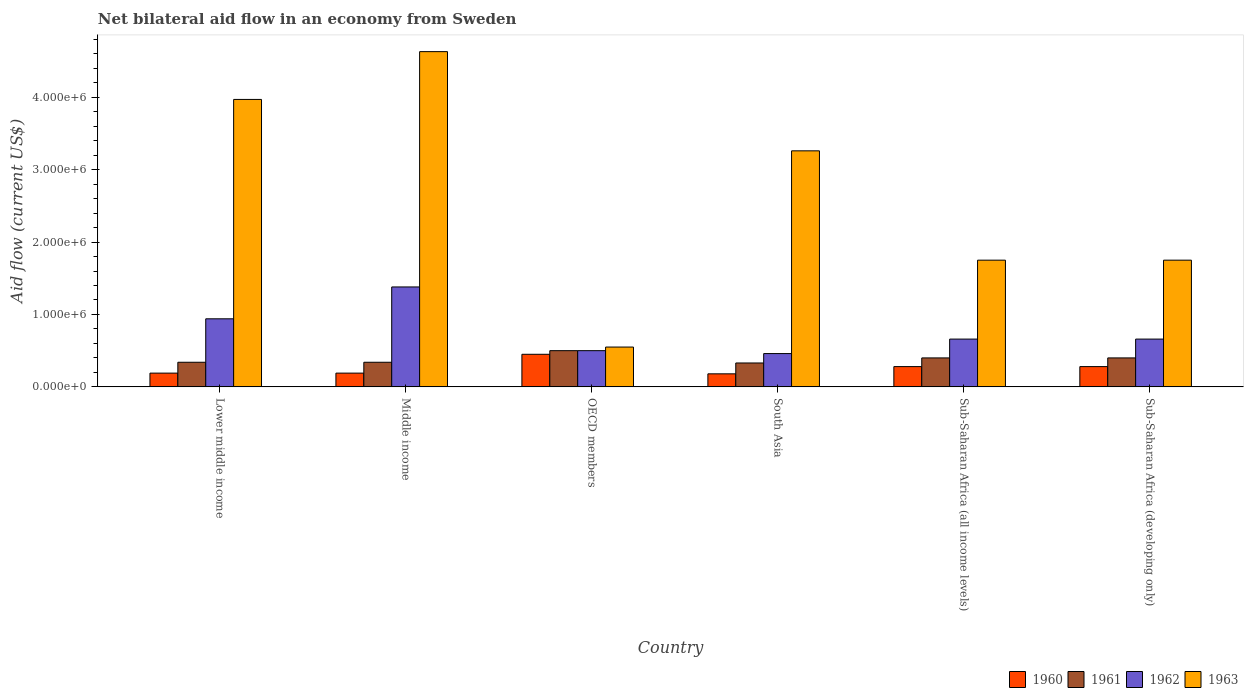How many different coloured bars are there?
Provide a short and direct response. 4. How many groups of bars are there?
Provide a succinct answer. 6. Are the number of bars on each tick of the X-axis equal?
Ensure brevity in your answer.  Yes. What is the label of the 5th group of bars from the left?
Your response must be concise. Sub-Saharan Africa (all income levels). What is the net bilateral aid flow in 1963 in Middle income?
Offer a very short reply. 4.63e+06. Across all countries, what is the maximum net bilateral aid flow in 1962?
Provide a succinct answer. 1.38e+06. Across all countries, what is the minimum net bilateral aid flow in 1960?
Your answer should be compact. 1.80e+05. In which country was the net bilateral aid flow in 1963 maximum?
Your response must be concise. Middle income. What is the total net bilateral aid flow in 1962 in the graph?
Provide a short and direct response. 4.60e+06. What is the difference between the net bilateral aid flow in 1961 in South Asia and that in Sub-Saharan Africa (all income levels)?
Make the answer very short. -7.00e+04. What is the difference between the net bilateral aid flow in 1962 in Sub-Saharan Africa (developing only) and the net bilateral aid flow in 1963 in Middle income?
Give a very brief answer. -3.97e+06. What is the average net bilateral aid flow in 1963 per country?
Your answer should be compact. 2.65e+06. What is the difference between the net bilateral aid flow of/in 1962 and net bilateral aid flow of/in 1961 in Middle income?
Keep it short and to the point. 1.04e+06. In how many countries, is the net bilateral aid flow in 1960 greater than 3200000 US$?
Offer a terse response. 0. What is the ratio of the net bilateral aid flow in 1961 in Sub-Saharan Africa (all income levels) to that in Sub-Saharan Africa (developing only)?
Offer a very short reply. 1. In how many countries, is the net bilateral aid flow in 1963 greater than the average net bilateral aid flow in 1963 taken over all countries?
Keep it short and to the point. 3. Is the sum of the net bilateral aid flow in 1960 in Middle income and OECD members greater than the maximum net bilateral aid flow in 1962 across all countries?
Your answer should be compact. No. What does the 4th bar from the left in Sub-Saharan Africa (developing only) represents?
Your response must be concise. 1963. What does the 2nd bar from the right in Sub-Saharan Africa (developing only) represents?
Make the answer very short. 1962. Is it the case that in every country, the sum of the net bilateral aid flow in 1960 and net bilateral aid flow in 1961 is greater than the net bilateral aid flow in 1962?
Offer a very short reply. No. How many bars are there?
Offer a very short reply. 24. Are all the bars in the graph horizontal?
Offer a very short reply. No. How many countries are there in the graph?
Offer a very short reply. 6. What is the difference between two consecutive major ticks on the Y-axis?
Your answer should be compact. 1.00e+06. Does the graph contain any zero values?
Offer a very short reply. No. How many legend labels are there?
Make the answer very short. 4. How are the legend labels stacked?
Your answer should be compact. Horizontal. What is the title of the graph?
Make the answer very short. Net bilateral aid flow in an economy from Sweden. Does "2004" appear as one of the legend labels in the graph?
Ensure brevity in your answer.  No. What is the label or title of the X-axis?
Your answer should be very brief. Country. What is the Aid flow (current US$) of 1961 in Lower middle income?
Your answer should be very brief. 3.40e+05. What is the Aid flow (current US$) of 1962 in Lower middle income?
Offer a very short reply. 9.40e+05. What is the Aid flow (current US$) in 1963 in Lower middle income?
Give a very brief answer. 3.97e+06. What is the Aid flow (current US$) of 1962 in Middle income?
Give a very brief answer. 1.38e+06. What is the Aid flow (current US$) of 1963 in Middle income?
Offer a very short reply. 4.63e+06. What is the Aid flow (current US$) in 1960 in OECD members?
Provide a succinct answer. 4.50e+05. What is the Aid flow (current US$) of 1962 in OECD members?
Your answer should be very brief. 5.00e+05. What is the Aid flow (current US$) in 1963 in OECD members?
Offer a very short reply. 5.50e+05. What is the Aid flow (current US$) in 1960 in South Asia?
Give a very brief answer. 1.80e+05. What is the Aid flow (current US$) in 1962 in South Asia?
Offer a terse response. 4.60e+05. What is the Aid flow (current US$) of 1963 in South Asia?
Give a very brief answer. 3.26e+06. What is the Aid flow (current US$) of 1963 in Sub-Saharan Africa (all income levels)?
Provide a short and direct response. 1.75e+06. What is the Aid flow (current US$) in 1962 in Sub-Saharan Africa (developing only)?
Ensure brevity in your answer.  6.60e+05. What is the Aid flow (current US$) of 1963 in Sub-Saharan Africa (developing only)?
Your response must be concise. 1.75e+06. Across all countries, what is the maximum Aid flow (current US$) in 1962?
Give a very brief answer. 1.38e+06. Across all countries, what is the maximum Aid flow (current US$) in 1963?
Your answer should be compact. 4.63e+06. Across all countries, what is the minimum Aid flow (current US$) of 1960?
Offer a very short reply. 1.80e+05. Across all countries, what is the minimum Aid flow (current US$) of 1961?
Ensure brevity in your answer.  3.30e+05. What is the total Aid flow (current US$) of 1960 in the graph?
Your response must be concise. 1.57e+06. What is the total Aid flow (current US$) in 1961 in the graph?
Ensure brevity in your answer.  2.31e+06. What is the total Aid flow (current US$) of 1962 in the graph?
Your answer should be compact. 4.60e+06. What is the total Aid flow (current US$) of 1963 in the graph?
Offer a terse response. 1.59e+07. What is the difference between the Aid flow (current US$) of 1960 in Lower middle income and that in Middle income?
Your response must be concise. 0. What is the difference between the Aid flow (current US$) of 1961 in Lower middle income and that in Middle income?
Ensure brevity in your answer.  0. What is the difference between the Aid flow (current US$) of 1962 in Lower middle income and that in Middle income?
Provide a short and direct response. -4.40e+05. What is the difference between the Aid flow (current US$) in 1963 in Lower middle income and that in Middle income?
Keep it short and to the point. -6.60e+05. What is the difference between the Aid flow (current US$) in 1960 in Lower middle income and that in OECD members?
Your response must be concise. -2.60e+05. What is the difference between the Aid flow (current US$) in 1962 in Lower middle income and that in OECD members?
Your answer should be very brief. 4.40e+05. What is the difference between the Aid flow (current US$) in 1963 in Lower middle income and that in OECD members?
Make the answer very short. 3.42e+06. What is the difference between the Aid flow (current US$) in 1961 in Lower middle income and that in South Asia?
Keep it short and to the point. 10000. What is the difference between the Aid flow (current US$) of 1962 in Lower middle income and that in South Asia?
Your answer should be very brief. 4.80e+05. What is the difference between the Aid flow (current US$) in 1963 in Lower middle income and that in South Asia?
Keep it short and to the point. 7.10e+05. What is the difference between the Aid flow (current US$) of 1960 in Lower middle income and that in Sub-Saharan Africa (all income levels)?
Your answer should be very brief. -9.00e+04. What is the difference between the Aid flow (current US$) of 1961 in Lower middle income and that in Sub-Saharan Africa (all income levels)?
Make the answer very short. -6.00e+04. What is the difference between the Aid flow (current US$) in 1962 in Lower middle income and that in Sub-Saharan Africa (all income levels)?
Keep it short and to the point. 2.80e+05. What is the difference between the Aid flow (current US$) in 1963 in Lower middle income and that in Sub-Saharan Africa (all income levels)?
Provide a succinct answer. 2.22e+06. What is the difference between the Aid flow (current US$) in 1960 in Lower middle income and that in Sub-Saharan Africa (developing only)?
Make the answer very short. -9.00e+04. What is the difference between the Aid flow (current US$) of 1963 in Lower middle income and that in Sub-Saharan Africa (developing only)?
Your response must be concise. 2.22e+06. What is the difference between the Aid flow (current US$) of 1962 in Middle income and that in OECD members?
Provide a succinct answer. 8.80e+05. What is the difference between the Aid flow (current US$) of 1963 in Middle income and that in OECD members?
Your answer should be compact. 4.08e+06. What is the difference between the Aid flow (current US$) of 1962 in Middle income and that in South Asia?
Your answer should be very brief. 9.20e+05. What is the difference between the Aid flow (current US$) of 1963 in Middle income and that in South Asia?
Offer a very short reply. 1.37e+06. What is the difference between the Aid flow (current US$) in 1960 in Middle income and that in Sub-Saharan Africa (all income levels)?
Provide a succinct answer. -9.00e+04. What is the difference between the Aid flow (current US$) of 1961 in Middle income and that in Sub-Saharan Africa (all income levels)?
Your answer should be very brief. -6.00e+04. What is the difference between the Aid flow (current US$) in 1962 in Middle income and that in Sub-Saharan Africa (all income levels)?
Make the answer very short. 7.20e+05. What is the difference between the Aid flow (current US$) of 1963 in Middle income and that in Sub-Saharan Africa (all income levels)?
Your response must be concise. 2.88e+06. What is the difference between the Aid flow (current US$) in 1960 in Middle income and that in Sub-Saharan Africa (developing only)?
Your answer should be very brief. -9.00e+04. What is the difference between the Aid flow (current US$) of 1962 in Middle income and that in Sub-Saharan Africa (developing only)?
Offer a very short reply. 7.20e+05. What is the difference between the Aid flow (current US$) in 1963 in Middle income and that in Sub-Saharan Africa (developing only)?
Provide a short and direct response. 2.88e+06. What is the difference between the Aid flow (current US$) in 1962 in OECD members and that in South Asia?
Your answer should be compact. 4.00e+04. What is the difference between the Aid flow (current US$) in 1963 in OECD members and that in South Asia?
Keep it short and to the point. -2.71e+06. What is the difference between the Aid flow (current US$) in 1960 in OECD members and that in Sub-Saharan Africa (all income levels)?
Provide a succinct answer. 1.70e+05. What is the difference between the Aid flow (current US$) of 1961 in OECD members and that in Sub-Saharan Africa (all income levels)?
Provide a short and direct response. 1.00e+05. What is the difference between the Aid flow (current US$) of 1962 in OECD members and that in Sub-Saharan Africa (all income levels)?
Your answer should be very brief. -1.60e+05. What is the difference between the Aid flow (current US$) of 1963 in OECD members and that in Sub-Saharan Africa (all income levels)?
Give a very brief answer. -1.20e+06. What is the difference between the Aid flow (current US$) in 1960 in OECD members and that in Sub-Saharan Africa (developing only)?
Keep it short and to the point. 1.70e+05. What is the difference between the Aid flow (current US$) of 1961 in OECD members and that in Sub-Saharan Africa (developing only)?
Your response must be concise. 1.00e+05. What is the difference between the Aid flow (current US$) in 1962 in OECD members and that in Sub-Saharan Africa (developing only)?
Your answer should be very brief. -1.60e+05. What is the difference between the Aid flow (current US$) of 1963 in OECD members and that in Sub-Saharan Africa (developing only)?
Your answer should be compact. -1.20e+06. What is the difference between the Aid flow (current US$) in 1961 in South Asia and that in Sub-Saharan Africa (all income levels)?
Keep it short and to the point. -7.00e+04. What is the difference between the Aid flow (current US$) of 1962 in South Asia and that in Sub-Saharan Africa (all income levels)?
Provide a succinct answer. -2.00e+05. What is the difference between the Aid flow (current US$) of 1963 in South Asia and that in Sub-Saharan Africa (all income levels)?
Give a very brief answer. 1.51e+06. What is the difference between the Aid flow (current US$) in 1960 in South Asia and that in Sub-Saharan Africa (developing only)?
Your answer should be very brief. -1.00e+05. What is the difference between the Aid flow (current US$) in 1961 in South Asia and that in Sub-Saharan Africa (developing only)?
Offer a terse response. -7.00e+04. What is the difference between the Aid flow (current US$) in 1962 in South Asia and that in Sub-Saharan Africa (developing only)?
Provide a short and direct response. -2.00e+05. What is the difference between the Aid flow (current US$) of 1963 in South Asia and that in Sub-Saharan Africa (developing only)?
Provide a short and direct response. 1.51e+06. What is the difference between the Aid flow (current US$) in 1960 in Lower middle income and the Aid flow (current US$) in 1961 in Middle income?
Your response must be concise. -1.50e+05. What is the difference between the Aid flow (current US$) in 1960 in Lower middle income and the Aid flow (current US$) in 1962 in Middle income?
Provide a succinct answer. -1.19e+06. What is the difference between the Aid flow (current US$) in 1960 in Lower middle income and the Aid flow (current US$) in 1963 in Middle income?
Ensure brevity in your answer.  -4.44e+06. What is the difference between the Aid flow (current US$) of 1961 in Lower middle income and the Aid flow (current US$) of 1962 in Middle income?
Provide a short and direct response. -1.04e+06. What is the difference between the Aid flow (current US$) of 1961 in Lower middle income and the Aid flow (current US$) of 1963 in Middle income?
Keep it short and to the point. -4.29e+06. What is the difference between the Aid flow (current US$) of 1962 in Lower middle income and the Aid flow (current US$) of 1963 in Middle income?
Offer a very short reply. -3.69e+06. What is the difference between the Aid flow (current US$) in 1960 in Lower middle income and the Aid flow (current US$) in 1961 in OECD members?
Ensure brevity in your answer.  -3.10e+05. What is the difference between the Aid flow (current US$) of 1960 in Lower middle income and the Aid flow (current US$) of 1962 in OECD members?
Your answer should be very brief. -3.10e+05. What is the difference between the Aid flow (current US$) of 1960 in Lower middle income and the Aid flow (current US$) of 1963 in OECD members?
Make the answer very short. -3.60e+05. What is the difference between the Aid flow (current US$) of 1961 in Lower middle income and the Aid flow (current US$) of 1963 in OECD members?
Provide a short and direct response. -2.10e+05. What is the difference between the Aid flow (current US$) in 1960 in Lower middle income and the Aid flow (current US$) in 1962 in South Asia?
Your answer should be very brief. -2.70e+05. What is the difference between the Aid flow (current US$) in 1960 in Lower middle income and the Aid flow (current US$) in 1963 in South Asia?
Your answer should be compact. -3.07e+06. What is the difference between the Aid flow (current US$) of 1961 in Lower middle income and the Aid flow (current US$) of 1963 in South Asia?
Your answer should be compact. -2.92e+06. What is the difference between the Aid flow (current US$) in 1962 in Lower middle income and the Aid flow (current US$) in 1963 in South Asia?
Provide a short and direct response. -2.32e+06. What is the difference between the Aid flow (current US$) in 1960 in Lower middle income and the Aid flow (current US$) in 1962 in Sub-Saharan Africa (all income levels)?
Offer a very short reply. -4.70e+05. What is the difference between the Aid flow (current US$) of 1960 in Lower middle income and the Aid flow (current US$) of 1963 in Sub-Saharan Africa (all income levels)?
Offer a very short reply. -1.56e+06. What is the difference between the Aid flow (current US$) of 1961 in Lower middle income and the Aid flow (current US$) of 1962 in Sub-Saharan Africa (all income levels)?
Ensure brevity in your answer.  -3.20e+05. What is the difference between the Aid flow (current US$) in 1961 in Lower middle income and the Aid flow (current US$) in 1963 in Sub-Saharan Africa (all income levels)?
Your answer should be very brief. -1.41e+06. What is the difference between the Aid flow (current US$) of 1962 in Lower middle income and the Aid flow (current US$) of 1963 in Sub-Saharan Africa (all income levels)?
Keep it short and to the point. -8.10e+05. What is the difference between the Aid flow (current US$) in 1960 in Lower middle income and the Aid flow (current US$) in 1962 in Sub-Saharan Africa (developing only)?
Offer a terse response. -4.70e+05. What is the difference between the Aid flow (current US$) in 1960 in Lower middle income and the Aid flow (current US$) in 1963 in Sub-Saharan Africa (developing only)?
Make the answer very short. -1.56e+06. What is the difference between the Aid flow (current US$) of 1961 in Lower middle income and the Aid flow (current US$) of 1962 in Sub-Saharan Africa (developing only)?
Give a very brief answer. -3.20e+05. What is the difference between the Aid flow (current US$) of 1961 in Lower middle income and the Aid flow (current US$) of 1963 in Sub-Saharan Africa (developing only)?
Keep it short and to the point. -1.41e+06. What is the difference between the Aid flow (current US$) of 1962 in Lower middle income and the Aid flow (current US$) of 1963 in Sub-Saharan Africa (developing only)?
Offer a terse response. -8.10e+05. What is the difference between the Aid flow (current US$) of 1960 in Middle income and the Aid flow (current US$) of 1961 in OECD members?
Provide a succinct answer. -3.10e+05. What is the difference between the Aid flow (current US$) in 1960 in Middle income and the Aid flow (current US$) in 1962 in OECD members?
Provide a short and direct response. -3.10e+05. What is the difference between the Aid flow (current US$) in 1960 in Middle income and the Aid flow (current US$) in 1963 in OECD members?
Offer a very short reply. -3.60e+05. What is the difference between the Aid flow (current US$) of 1961 in Middle income and the Aid flow (current US$) of 1962 in OECD members?
Keep it short and to the point. -1.60e+05. What is the difference between the Aid flow (current US$) in 1961 in Middle income and the Aid flow (current US$) in 1963 in OECD members?
Your answer should be compact. -2.10e+05. What is the difference between the Aid flow (current US$) in 1962 in Middle income and the Aid flow (current US$) in 1963 in OECD members?
Your answer should be compact. 8.30e+05. What is the difference between the Aid flow (current US$) in 1960 in Middle income and the Aid flow (current US$) in 1962 in South Asia?
Your response must be concise. -2.70e+05. What is the difference between the Aid flow (current US$) of 1960 in Middle income and the Aid flow (current US$) of 1963 in South Asia?
Provide a succinct answer. -3.07e+06. What is the difference between the Aid flow (current US$) in 1961 in Middle income and the Aid flow (current US$) in 1962 in South Asia?
Ensure brevity in your answer.  -1.20e+05. What is the difference between the Aid flow (current US$) of 1961 in Middle income and the Aid flow (current US$) of 1963 in South Asia?
Provide a succinct answer. -2.92e+06. What is the difference between the Aid flow (current US$) of 1962 in Middle income and the Aid flow (current US$) of 1963 in South Asia?
Provide a short and direct response. -1.88e+06. What is the difference between the Aid flow (current US$) in 1960 in Middle income and the Aid flow (current US$) in 1962 in Sub-Saharan Africa (all income levels)?
Make the answer very short. -4.70e+05. What is the difference between the Aid flow (current US$) of 1960 in Middle income and the Aid flow (current US$) of 1963 in Sub-Saharan Africa (all income levels)?
Offer a terse response. -1.56e+06. What is the difference between the Aid flow (current US$) of 1961 in Middle income and the Aid flow (current US$) of 1962 in Sub-Saharan Africa (all income levels)?
Offer a terse response. -3.20e+05. What is the difference between the Aid flow (current US$) in 1961 in Middle income and the Aid flow (current US$) in 1963 in Sub-Saharan Africa (all income levels)?
Make the answer very short. -1.41e+06. What is the difference between the Aid flow (current US$) in 1962 in Middle income and the Aid flow (current US$) in 1963 in Sub-Saharan Africa (all income levels)?
Your answer should be very brief. -3.70e+05. What is the difference between the Aid flow (current US$) in 1960 in Middle income and the Aid flow (current US$) in 1961 in Sub-Saharan Africa (developing only)?
Your answer should be compact. -2.10e+05. What is the difference between the Aid flow (current US$) of 1960 in Middle income and the Aid flow (current US$) of 1962 in Sub-Saharan Africa (developing only)?
Your response must be concise. -4.70e+05. What is the difference between the Aid flow (current US$) of 1960 in Middle income and the Aid flow (current US$) of 1963 in Sub-Saharan Africa (developing only)?
Provide a short and direct response. -1.56e+06. What is the difference between the Aid flow (current US$) of 1961 in Middle income and the Aid flow (current US$) of 1962 in Sub-Saharan Africa (developing only)?
Your response must be concise. -3.20e+05. What is the difference between the Aid flow (current US$) of 1961 in Middle income and the Aid flow (current US$) of 1963 in Sub-Saharan Africa (developing only)?
Offer a very short reply. -1.41e+06. What is the difference between the Aid flow (current US$) of 1962 in Middle income and the Aid flow (current US$) of 1963 in Sub-Saharan Africa (developing only)?
Offer a very short reply. -3.70e+05. What is the difference between the Aid flow (current US$) in 1960 in OECD members and the Aid flow (current US$) in 1961 in South Asia?
Provide a short and direct response. 1.20e+05. What is the difference between the Aid flow (current US$) in 1960 in OECD members and the Aid flow (current US$) in 1963 in South Asia?
Offer a very short reply. -2.81e+06. What is the difference between the Aid flow (current US$) of 1961 in OECD members and the Aid flow (current US$) of 1963 in South Asia?
Ensure brevity in your answer.  -2.76e+06. What is the difference between the Aid flow (current US$) in 1962 in OECD members and the Aid flow (current US$) in 1963 in South Asia?
Ensure brevity in your answer.  -2.76e+06. What is the difference between the Aid flow (current US$) of 1960 in OECD members and the Aid flow (current US$) of 1961 in Sub-Saharan Africa (all income levels)?
Your answer should be compact. 5.00e+04. What is the difference between the Aid flow (current US$) in 1960 in OECD members and the Aid flow (current US$) in 1962 in Sub-Saharan Africa (all income levels)?
Keep it short and to the point. -2.10e+05. What is the difference between the Aid flow (current US$) in 1960 in OECD members and the Aid flow (current US$) in 1963 in Sub-Saharan Africa (all income levels)?
Your response must be concise. -1.30e+06. What is the difference between the Aid flow (current US$) in 1961 in OECD members and the Aid flow (current US$) in 1962 in Sub-Saharan Africa (all income levels)?
Offer a very short reply. -1.60e+05. What is the difference between the Aid flow (current US$) of 1961 in OECD members and the Aid flow (current US$) of 1963 in Sub-Saharan Africa (all income levels)?
Your response must be concise. -1.25e+06. What is the difference between the Aid flow (current US$) in 1962 in OECD members and the Aid flow (current US$) in 1963 in Sub-Saharan Africa (all income levels)?
Your answer should be very brief. -1.25e+06. What is the difference between the Aid flow (current US$) in 1960 in OECD members and the Aid flow (current US$) in 1963 in Sub-Saharan Africa (developing only)?
Make the answer very short. -1.30e+06. What is the difference between the Aid flow (current US$) of 1961 in OECD members and the Aid flow (current US$) of 1962 in Sub-Saharan Africa (developing only)?
Your response must be concise. -1.60e+05. What is the difference between the Aid flow (current US$) in 1961 in OECD members and the Aid flow (current US$) in 1963 in Sub-Saharan Africa (developing only)?
Ensure brevity in your answer.  -1.25e+06. What is the difference between the Aid flow (current US$) in 1962 in OECD members and the Aid flow (current US$) in 1963 in Sub-Saharan Africa (developing only)?
Ensure brevity in your answer.  -1.25e+06. What is the difference between the Aid flow (current US$) of 1960 in South Asia and the Aid flow (current US$) of 1961 in Sub-Saharan Africa (all income levels)?
Your answer should be compact. -2.20e+05. What is the difference between the Aid flow (current US$) of 1960 in South Asia and the Aid flow (current US$) of 1962 in Sub-Saharan Africa (all income levels)?
Offer a very short reply. -4.80e+05. What is the difference between the Aid flow (current US$) in 1960 in South Asia and the Aid flow (current US$) in 1963 in Sub-Saharan Africa (all income levels)?
Provide a short and direct response. -1.57e+06. What is the difference between the Aid flow (current US$) of 1961 in South Asia and the Aid flow (current US$) of 1962 in Sub-Saharan Africa (all income levels)?
Give a very brief answer. -3.30e+05. What is the difference between the Aid flow (current US$) in 1961 in South Asia and the Aid flow (current US$) in 1963 in Sub-Saharan Africa (all income levels)?
Provide a succinct answer. -1.42e+06. What is the difference between the Aid flow (current US$) in 1962 in South Asia and the Aid flow (current US$) in 1963 in Sub-Saharan Africa (all income levels)?
Offer a very short reply. -1.29e+06. What is the difference between the Aid flow (current US$) of 1960 in South Asia and the Aid flow (current US$) of 1961 in Sub-Saharan Africa (developing only)?
Your response must be concise. -2.20e+05. What is the difference between the Aid flow (current US$) in 1960 in South Asia and the Aid flow (current US$) in 1962 in Sub-Saharan Africa (developing only)?
Your answer should be very brief. -4.80e+05. What is the difference between the Aid flow (current US$) in 1960 in South Asia and the Aid flow (current US$) in 1963 in Sub-Saharan Africa (developing only)?
Keep it short and to the point. -1.57e+06. What is the difference between the Aid flow (current US$) of 1961 in South Asia and the Aid flow (current US$) of 1962 in Sub-Saharan Africa (developing only)?
Make the answer very short. -3.30e+05. What is the difference between the Aid flow (current US$) in 1961 in South Asia and the Aid flow (current US$) in 1963 in Sub-Saharan Africa (developing only)?
Keep it short and to the point. -1.42e+06. What is the difference between the Aid flow (current US$) of 1962 in South Asia and the Aid flow (current US$) of 1963 in Sub-Saharan Africa (developing only)?
Offer a very short reply. -1.29e+06. What is the difference between the Aid flow (current US$) of 1960 in Sub-Saharan Africa (all income levels) and the Aid flow (current US$) of 1961 in Sub-Saharan Africa (developing only)?
Offer a very short reply. -1.20e+05. What is the difference between the Aid flow (current US$) in 1960 in Sub-Saharan Africa (all income levels) and the Aid flow (current US$) in 1962 in Sub-Saharan Africa (developing only)?
Offer a terse response. -3.80e+05. What is the difference between the Aid flow (current US$) of 1960 in Sub-Saharan Africa (all income levels) and the Aid flow (current US$) of 1963 in Sub-Saharan Africa (developing only)?
Your response must be concise. -1.47e+06. What is the difference between the Aid flow (current US$) in 1961 in Sub-Saharan Africa (all income levels) and the Aid flow (current US$) in 1963 in Sub-Saharan Africa (developing only)?
Keep it short and to the point. -1.35e+06. What is the difference between the Aid flow (current US$) in 1962 in Sub-Saharan Africa (all income levels) and the Aid flow (current US$) in 1963 in Sub-Saharan Africa (developing only)?
Your answer should be compact. -1.09e+06. What is the average Aid flow (current US$) of 1960 per country?
Your answer should be compact. 2.62e+05. What is the average Aid flow (current US$) in 1961 per country?
Give a very brief answer. 3.85e+05. What is the average Aid flow (current US$) of 1962 per country?
Make the answer very short. 7.67e+05. What is the average Aid flow (current US$) in 1963 per country?
Your answer should be compact. 2.65e+06. What is the difference between the Aid flow (current US$) in 1960 and Aid flow (current US$) in 1961 in Lower middle income?
Keep it short and to the point. -1.50e+05. What is the difference between the Aid flow (current US$) of 1960 and Aid flow (current US$) of 1962 in Lower middle income?
Your answer should be compact. -7.50e+05. What is the difference between the Aid flow (current US$) in 1960 and Aid flow (current US$) in 1963 in Lower middle income?
Make the answer very short. -3.78e+06. What is the difference between the Aid flow (current US$) of 1961 and Aid flow (current US$) of 1962 in Lower middle income?
Keep it short and to the point. -6.00e+05. What is the difference between the Aid flow (current US$) of 1961 and Aid flow (current US$) of 1963 in Lower middle income?
Your answer should be very brief. -3.63e+06. What is the difference between the Aid flow (current US$) of 1962 and Aid flow (current US$) of 1963 in Lower middle income?
Make the answer very short. -3.03e+06. What is the difference between the Aid flow (current US$) of 1960 and Aid flow (current US$) of 1961 in Middle income?
Provide a short and direct response. -1.50e+05. What is the difference between the Aid flow (current US$) of 1960 and Aid flow (current US$) of 1962 in Middle income?
Your answer should be very brief. -1.19e+06. What is the difference between the Aid flow (current US$) in 1960 and Aid flow (current US$) in 1963 in Middle income?
Offer a terse response. -4.44e+06. What is the difference between the Aid flow (current US$) in 1961 and Aid flow (current US$) in 1962 in Middle income?
Offer a terse response. -1.04e+06. What is the difference between the Aid flow (current US$) in 1961 and Aid flow (current US$) in 1963 in Middle income?
Ensure brevity in your answer.  -4.29e+06. What is the difference between the Aid flow (current US$) of 1962 and Aid flow (current US$) of 1963 in Middle income?
Your answer should be compact. -3.25e+06. What is the difference between the Aid flow (current US$) in 1960 and Aid flow (current US$) in 1961 in OECD members?
Make the answer very short. -5.00e+04. What is the difference between the Aid flow (current US$) of 1960 and Aid flow (current US$) of 1962 in OECD members?
Your answer should be very brief. -5.00e+04. What is the difference between the Aid flow (current US$) in 1960 and Aid flow (current US$) in 1963 in OECD members?
Give a very brief answer. -1.00e+05. What is the difference between the Aid flow (current US$) in 1960 and Aid flow (current US$) in 1961 in South Asia?
Give a very brief answer. -1.50e+05. What is the difference between the Aid flow (current US$) of 1960 and Aid flow (current US$) of 1962 in South Asia?
Provide a succinct answer. -2.80e+05. What is the difference between the Aid flow (current US$) of 1960 and Aid flow (current US$) of 1963 in South Asia?
Provide a succinct answer. -3.08e+06. What is the difference between the Aid flow (current US$) of 1961 and Aid flow (current US$) of 1963 in South Asia?
Offer a very short reply. -2.93e+06. What is the difference between the Aid flow (current US$) of 1962 and Aid flow (current US$) of 1963 in South Asia?
Your answer should be compact. -2.80e+06. What is the difference between the Aid flow (current US$) of 1960 and Aid flow (current US$) of 1961 in Sub-Saharan Africa (all income levels)?
Your answer should be very brief. -1.20e+05. What is the difference between the Aid flow (current US$) of 1960 and Aid flow (current US$) of 1962 in Sub-Saharan Africa (all income levels)?
Your answer should be compact. -3.80e+05. What is the difference between the Aid flow (current US$) in 1960 and Aid flow (current US$) in 1963 in Sub-Saharan Africa (all income levels)?
Make the answer very short. -1.47e+06. What is the difference between the Aid flow (current US$) of 1961 and Aid flow (current US$) of 1963 in Sub-Saharan Africa (all income levels)?
Keep it short and to the point. -1.35e+06. What is the difference between the Aid flow (current US$) in 1962 and Aid flow (current US$) in 1963 in Sub-Saharan Africa (all income levels)?
Your answer should be compact. -1.09e+06. What is the difference between the Aid flow (current US$) of 1960 and Aid flow (current US$) of 1961 in Sub-Saharan Africa (developing only)?
Offer a very short reply. -1.20e+05. What is the difference between the Aid flow (current US$) of 1960 and Aid flow (current US$) of 1962 in Sub-Saharan Africa (developing only)?
Your answer should be compact. -3.80e+05. What is the difference between the Aid flow (current US$) in 1960 and Aid flow (current US$) in 1963 in Sub-Saharan Africa (developing only)?
Your answer should be compact. -1.47e+06. What is the difference between the Aid flow (current US$) of 1961 and Aid flow (current US$) of 1962 in Sub-Saharan Africa (developing only)?
Ensure brevity in your answer.  -2.60e+05. What is the difference between the Aid flow (current US$) of 1961 and Aid flow (current US$) of 1963 in Sub-Saharan Africa (developing only)?
Provide a succinct answer. -1.35e+06. What is the difference between the Aid flow (current US$) in 1962 and Aid flow (current US$) in 1963 in Sub-Saharan Africa (developing only)?
Ensure brevity in your answer.  -1.09e+06. What is the ratio of the Aid flow (current US$) of 1960 in Lower middle income to that in Middle income?
Your answer should be compact. 1. What is the ratio of the Aid flow (current US$) of 1962 in Lower middle income to that in Middle income?
Offer a very short reply. 0.68. What is the ratio of the Aid flow (current US$) of 1963 in Lower middle income to that in Middle income?
Keep it short and to the point. 0.86. What is the ratio of the Aid flow (current US$) of 1960 in Lower middle income to that in OECD members?
Give a very brief answer. 0.42. What is the ratio of the Aid flow (current US$) of 1961 in Lower middle income to that in OECD members?
Keep it short and to the point. 0.68. What is the ratio of the Aid flow (current US$) in 1962 in Lower middle income to that in OECD members?
Provide a short and direct response. 1.88. What is the ratio of the Aid flow (current US$) of 1963 in Lower middle income to that in OECD members?
Ensure brevity in your answer.  7.22. What is the ratio of the Aid flow (current US$) in 1960 in Lower middle income to that in South Asia?
Provide a short and direct response. 1.06. What is the ratio of the Aid flow (current US$) in 1961 in Lower middle income to that in South Asia?
Your response must be concise. 1.03. What is the ratio of the Aid flow (current US$) of 1962 in Lower middle income to that in South Asia?
Make the answer very short. 2.04. What is the ratio of the Aid flow (current US$) of 1963 in Lower middle income to that in South Asia?
Give a very brief answer. 1.22. What is the ratio of the Aid flow (current US$) in 1960 in Lower middle income to that in Sub-Saharan Africa (all income levels)?
Provide a succinct answer. 0.68. What is the ratio of the Aid flow (current US$) of 1961 in Lower middle income to that in Sub-Saharan Africa (all income levels)?
Your answer should be very brief. 0.85. What is the ratio of the Aid flow (current US$) of 1962 in Lower middle income to that in Sub-Saharan Africa (all income levels)?
Provide a short and direct response. 1.42. What is the ratio of the Aid flow (current US$) of 1963 in Lower middle income to that in Sub-Saharan Africa (all income levels)?
Offer a terse response. 2.27. What is the ratio of the Aid flow (current US$) in 1960 in Lower middle income to that in Sub-Saharan Africa (developing only)?
Give a very brief answer. 0.68. What is the ratio of the Aid flow (current US$) in 1961 in Lower middle income to that in Sub-Saharan Africa (developing only)?
Ensure brevity in your answer.  0.85. What is the ratio of the Aid flow (current US$) of 1962 in Lower middle income to that in Sub-Saharan Africa (developing only)?
Offer a terse response. 1.42. What is the ratio of the Aid flow (current US$) in 1963 in Lower middle income to that in Sub-Saharan Africa (developing only)?
Offer a terse response. 2.27. What is the ratio of the Aid flow (current US$) in 1960 in Middle income to that in OECD members?
Your answer should be very brief. 0.42. What is the ratio of the Aid flow (current US$) in 1961 in Middle income to that in OECD members?
Provide a short and direct response. 0.68. What is the ratio of the Aid flow (current US$) in 1962 in Middle income to that in OECD members?
Give a very brief answer. 2.76. What is the ratio of the Aid flow (current US$) in 1963 in Middle income to that in OECD members?
Your response must be concise. 8.42. What is the ratio of the Aid flow (current US$) in 1960 in Middle income to that in South Asia?
Offer a very short reply. 1.06. What is the ratio of the Aid flow (current US$) of 1961 in Middle income to that in South Asia?
Your answer should be very brief. 1.03. What is the ratio of the Aid flow (current US$) of 1963 in Middle income to that in South Asia?
Offer a very short reply. 1.42. What is the ratio of the Aid flow (current US$) in 1960 in Middle income to that in Sub-Saharan Africa (all income levels)?
Keep it short and to the point. 0.68. What is the ratio of the Aid flow (current US$) in 1962 in Middle income to that in Sub-Saharan Africa (all income levels)?
Keep it short and to the point. 2.09. What is the ratio of the Aid flow (current US$) of 1963 in Middle income to that in Sub-Saharan Africa (all income levels)?
Offer a terse response. 2.65. What is the ratio of the Aid flow (current US$) in 1960 in Middle income to that in Sub-Saharan Africa (developing only)?
Offer a terse response. 0.68. What is the ratio of the Aid flow (current US$) in 1961 in Middle income to that in Sub-Saharan Africa (developing only)?
Provide a short and direct response. 0.85. What is the ratio of the Aid flow (current US$) in 1962 in Middle income to that in Sub-Saharan Africa (developing only)?
Your response must be concise. 2.09. What is the ratio of the Aid flow (current US$) in 1963 in Middle income to that in Sub-Saharan Africa (developing only)?
Offer a very short reply. 2.65. What is the ratio of the Aid flow (current US$) in 1960 in OECD members to that in South Asia?
Provide a succinct answer. 2.5. What is the ratio of the Aid flow (current US$) in 1961 in OECD members to that in South Asia?
Offer a very short reply. 1.52. What is the ratio of the Aid flow (current US$) in 1962 in OECD members to that in South Asia?
Keep it short and to the point. 1.09. What is the ratio of the Aid flow (current US$) of 1963 in OECD members to that in South Asia?
Your answer should be very brief. 0.17. What is the ratio of the Aid flow (current US$) in 1960 in OECD members to that in Sub-Saharan Africa (all income levels)?
Provide a succinct answer. 1.61. What is the ratio of the Aid flow (current US$) of 1962 in OECD members to that in Sub-Saharan Africa (all income levels)?
Offer a terse response. 0.76. What is the ratio of the Aid flow (current US$) of 1963 in OECD members to that in Sub-Saharan Africa (all income levels)?
Ensure brevity in your answer.  0.31. What is the ratio of the Aid flow (current US$) of 1960 in OECD members to that in Sub-Saharan Africa (developing only)?
Provide a short and direct response. 1.61. What is the ratio of the Aid flow (current US$) in 1961 in OECD members to that in Sub-Saharan Africa (developing only)?
Ensure brevity in your answer.  1.25. What is the ratio of the Aid flow (current US$) of 1962 in OECD members to that in Sub-Saharan Africa (developing only)?
Your response must be concise. 0.76. What is the ratio of the Aid flow (current US$) in 1963 in OECD members to that in Sub-Saharan Africa (developing only)?
Provide a succinct answer. 0.31. What is the ratio of the Aid flow (current US$) of 1960 in South Asia to that in Sub-Saharan Africa (all income levels)?
Offer a very short reply. 0.64. What is the ratio of the Aid flow (current US$) of 1961 in South Asia to that in Sub-Saharan Africa (all income levels)?
Your response must be concise. 0.82. What is the ratio of the Aid flow (current US$) in 1962 in South Asia to that in Sub-Saharan Africa (all income levels)?
Provide a short and direct response. 0.7. What is the ratio of the Aid flow (current US$) of 1963 in South Asia to that in Sub-Saharan Africa (all income levels)?
Your answer should be very brief. 1.86. What is the ratio of the Aid flow (current US$) of 1960 in South Asia to that in Sub-Saharan Africa (developing only)?
Keep it short and to the point. 0.64. What is the ratio of the Aid flow (current US$) in 1961 in South Asia to that in Sub-Saharan Africa (developing only)?
Your response must be concise. 0.82. What is the ratio of the Aid flow (current US$) of 1962 in South Asia to that in Sub-Saharan Africa (developing only)?
Offer a terse response. 0.7. What is the ratio of the Aid flow (current US$) of 1963 in South Asia to that in Sub-Saharan Africa (developing only)?
Make the answer very short. 1.86. What is the ratio of the Aid flow (current US$) in 1961 in Sub-Saharan Africa (all income levels) to that in Sub-Saharan Africa (developing only)?
Provide a short and direct response. 1. What is the ratio of the Aid flow (current US$) in 1963 in Sub-Saharan Africa (all income levels) to that in Sub-Saharan Africa (developing only)?
Provide a short and direct response. 1. What is the difference between the highest and the second highest Aid flow (current US$) of 1960?
Ensure brevity in your answer.  1.70e+05. What is the difference between the highest and the second highest Aid flow (current US$) in 1962?
Keep it short and to the point. 4.40e+05. What is the difference between the highest and the second highest Aid flow (current US$) of 1963?
Make the answer very short. 6.60e+05. What is the difference between the highest and the lowest Aid flow (current US$) of 1961?
Your answer should be compact. 1.70e+05. What is the difference between the highest and the lowest Aid flow (current US$) of 1962?
Your answer should be compact. 9.20e+05. What is the difference between the highest and the lowest Aid flow (current US$) of 1963?
Offer a very short reply. 4.08e+06. 